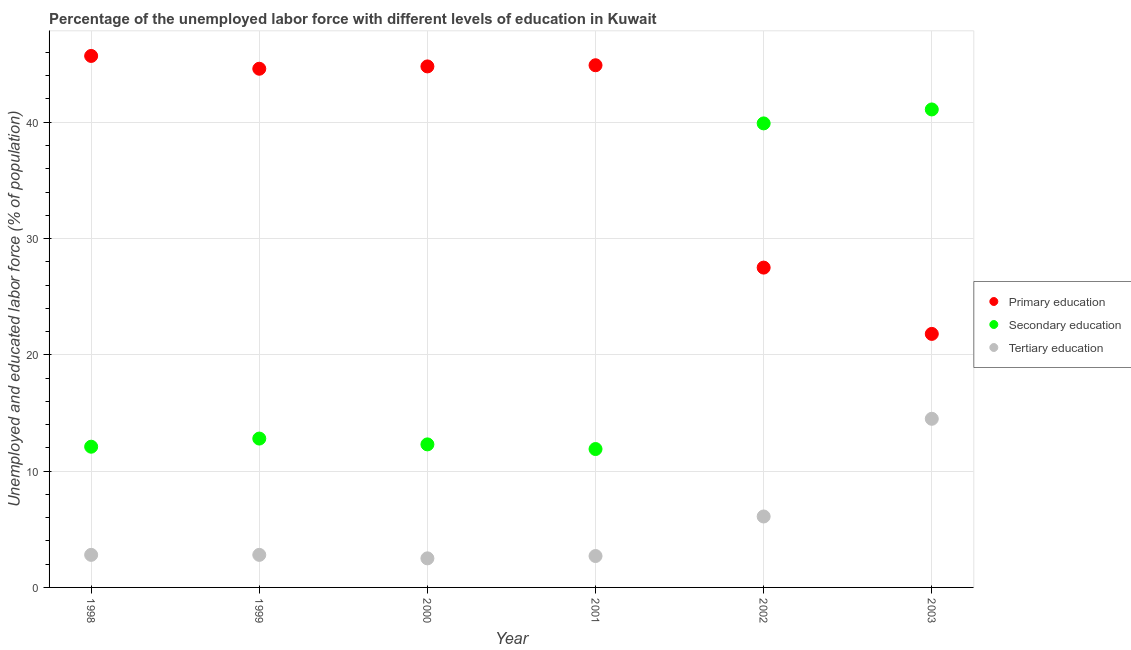Is the number of dotlines equal to the number of legend labels?
Provide a succinct answer. Yes. What is the percentage of labor force who received tertiary education in 2002?
Your answer should be compact. 6.1. Across all years, what is the maximum percentage of labor force who received primary education?
Your answer should be very brief. 45.7. Across all years, what is the minimum percentage of labor force who received primary education?
Make the answer very short. 21.8. In which year was the percentage of labor force who received secondary education maximum?
Provide a short and direct response. 2003. In which year was the percentage of labor force who received primary education minimum?
Ensure brevity in your answer.  2003. What is the total percentage of labor force who received secondary education in the graph?
Your answer should be very brief. 130.1. What is the difference between the percentage of labor force who received primary education in 2002 and that in 2003?
Your answer should be very brief. 5.7. What is the difference between the percentage of labor force who received tertiary education in 2002 and the percentage of labor force who received secondary education in 1998?
Provide a short and direct response. -6. What is the average percentage of labor force who received primary education per year?
Offer a very short reply. 38.22. In the year 2003, what is the difference between the percentage of labor force who received tertiary education and percentage of labor force who received secondary education?
Offer a terse response. -26.6. In how many years, is the percentage of labor force who received primary education greater than 16 %?
Ensure brevity in your answer.  6. What is the ratio of the percentage of labor force who received secondary education in 1999 to that in 2001?
Your answer should be very brief. 1.08. Is the percentage of labor force who received primary education in 1998 less than that in 2003?
Keep it short and to the point. No. What is the difference between the highest and the second highest percentage of labor force who received primary education?
Your answer should be compact. 0.8. What is the difference between the highest and the lowest percentage of labor force who received primary education?
Ensure brevity in your answer.  23.9. In how many years, is the percentage of labor force who received primary education greater than the average percentage of labor force who received primary education taken over all years?
Your answer should be compact. 4. Is the sum of the percentage of labor force who received secondary education in 1999 and 2003 greater than the maximum percentage of labor force who received tertiary education across all years?
Your answer should be compact. Yes. How many dotlines are there?
Your answer should be very brief. 3. Does the graph contain any zero values?
Ensure brevity in your answer.  No. Does the graph contain grids?
Make the answer very short. Yes. How many legend labels are there?
Offer a very short reply. 3. How are the legend labels stacked?
Your answer should be very brief. Vertical. What is the title of the graph?
Your answer should be compact. Percentage of the unemployed labor force with different levels of education in Kuwait. Does "Liquid fuel" appear as one of the legend labels in the graph?
Make the answer very short. No. What is the label or title of the Y-axis?
Ensure brevity in your answer.  Unemployed and educated labor force (% of population). What is the Unemployed and educated labor force (% of population) of Primary education in 1998?
Provide a short and direct response. 45.7. What is the Unemployed and educated labor force (% of population) of Secondary education in 1998?
Make the answer very short. 12.1. What is the Unemployed and educated labor force (% of population) in Tertiary education in 1998?
Ensure brevity in your answer.  2.8. What is the Unemployed and educated labor force (% of population) of Primary education in 1999?
Offer a very short reply. 44.6. What is the Unemployed and educated labor force (% of population) of Secondary education in 1999?
Make the answer very short. 12.8. What is the Unemployed and educated labor force (% of population) in Tertiary education in 1999?
Your answer should be compact. 2.8. What is the Unemployed and educated labor force (% of population) in Primary education in 2000?
Keep it short and to the point. 44.8. What is the Unemployed and educated labor force (% of population) in Secondary education in 2000?
Offer a terse response. 12.3. What is the Unemployed and educated labor force (% of population) of Tertiary education in 2000?
Offer a very short reply. 2.5. What is the Unemployed and educated labor force (% of population) in Primary education in 2001?
Provide a short and direct response. 44.9. What is the Unemployed and educated labor force (% of population) in Secondary education in 2001?
Offer a terse response. 11.9. What is the Unemployed and educated labor force (% of population) of Tertiary education in 2001?
Keep it short and to the point. 2.7. What is the Unemployed and educated labor force (% of population) of Primary education in 2002?
Offer a very short reply. 27.5. What is the Unemployed and educated labor force (% of population) of Secondary education in 2002?
Provide a succinct answer. 39.9. What is the Unemployed and educated labor force (% of population) in Tertiary education in 2002?
Offer a very short reply. 6.1. What is the Unemployed and educated labor force (% of population) in Primary education in 2003?
Provide a short and direct response. 21.8. What is the Unemployed and educated labor force (% of population) of Secondary education in 2003?
Your response must be concise. 41.1. Across all years, what is the maximum Unemployed and educated labor force (% of population) in Primary education?
Offer a terse response. 45.7. Across all years, what is the maximum Unemployed and educated labor force (% of population) in Secondary education?
Ensure brevity in your answer.  41.1. Across all years, what is the minimum Unemployed and educated labor force (% of population) of Primary education?
Provide a short and direct response. 21.8. Across all years, what is the minimum Unemployed and educated labor force (% of population) in Secondary education?
Make the answer very short. 11.9. What is the total Unemployed and educated labor force (% of population) in Primary education in the graph?
Keep it short and to the point. 229.3. What is the total Unemployed and educated labor force (% of population) in Secondary education in the graph?
Your response must be concise. 130.1. What is the total Unemployed and educated labor force (% of population) in Tertiary education in the graph?
Your response must be concise. 31.4. What is the difference between the Unemployed and educated labor force (% of population) in Tertiary education in 1998 and that in 1999?
Give a very brief answer. 0. What is the difference between the Unemployed and educated labor force (% of population) of Secondary education in 1998 and that in 2000?
Ensure brevity in your answer.  -0.2. What is the difference between the Unemployed and educated labor force (% of population) in Tertiary education in 1998 and that in 2000?
Make the answer very short. 0.3. What is the difference between the Unemployed and educated labor force (% of population) of Primary education in 1998 and that in 2001?
Your answer should be very brief. 0.8. What is the difference between the Unemployed and educated labor force (% of population) in Secondary education in 1998 and that in 2001?
Your response must be concise. 0.2. What is the difference between the Unemployed and educated labor force (% of population) in Secondary education in 1998 and that in 2002?
Your answer should be compact. -27.8. What is the difference between the Unemployed and educated labor force (% of population) in Tertiary education in 1998 and that in 2002?
Your answer should be compact. -3.3. What is the difference between the Unemployed and educated labor force (% of population) in Primary education in 1998 and that in 2003?
Ensure brevity in your answer.  23.9. What is the difference between the Unemployed and educated labor force (% of population) in Primary education in 1999 and that in 2000?
Your response must be concise. -0.2. What is the difference between the Unemployed and educated labor force (% of population) in Tertiary education in 1999 and that in 2000?
Provide a short and direct response. 0.3. What is the difference between the Unemployed and educated labor force (% of population) in Primary education in 1999 and that in 2001?
Make the answer very short. -0.3. What is the difference between the Unemployed and educated labor force (% of population) of Secondary education in 1999 and that in 2002?
Provide a short and direct response. -27.1. What is the difference between the Unemployed and educated labor force (% of population) in Tertiary education in 1999 and that in 2002?
Keep it short and to the point. -3.3. What is the difference between the Unemployed and educated labor force (% of population) of Primary education in 1999 and that in 2003?
Offer a terse response. 22.8. What is the difference between the Unemployed and educated labor force (% of population) of Secondary education in 1999 and that in 2003?
Keep it short and to the point. -28.3. What is the difference between the Unemployed and educated labor force (% of population) in Tertiary education in 1999 and that in 2003?
Provide a short and direct response. -11.7. What is the difference between the Unemployed and educated labor force (% of population) of Primary education in 2000 and that in 2001?
Ensure brevity in your answer.  -0.1. What is the difference between the Unemployed and educated labor force (% of population) in Secondary education in 2000 and that in 2001?
Ensure brevity in your answer.  0.4. What is the difference between the Unemployed and educated labor force (% of population) in Tertiary education in 2000 and that in 2001?
Give a very brief answer. -0.2. What is the difference between the Unemployed and educated labor force (% of population) in Secondary education in 2000 and that in 2002?
Make the answer very short. -27.6. What is the difference between the Unemployed and educated labor force (% of population) in Secondary education in 2000 and that in 2003?
Offer a terse response. -28.8. What is the difference between the Unemployed and educated labor force (% of population) of Primary education in 2001 and that in 2002?
Your response must be concise. 17.4. What is the difference between the Unemployed and educated labor force (% of population) of Secondary education in 2001 and that in 2002?
Ensure brevity in your answer.  -28. What is the difference between the Unemployed and educated labor force (% of population) in Primary education in 2001 and that in 2003?
Your response must be concise. 23.1. What is the difference between the Unemployed and educated labor force (% of population) of Secondary education in 2001 and that in 2003?
Your answer should be very brief. -29.2. What is the difference between the Unemployed and educated labor force (% of population) of Tertiary education in 2001 and that in 2003?
Your answer should be very brief. -11.8. What is the difference between the Unemployed and educated labor force (% of population) in Secondary education in 2002 and that in 2003?
Make the answer very short. -1.2. What is the difference between the Unemployed and educated labor force (% of population) of Primary education in 1998 and the Unemployed and educated labor force (% of population) of Secondary education in 1999?
Offer a terse response. 32.9. What is the difference between the Unemployed and educated labor force (% of population) of Primary education in 1998 and the Unemployed and educated labor force (% of population) of Tertiary education in 1999?
Your answer should be very brief. 42.9. What is the difference between the Unemployed and educated labor force (% of population) of Primary education in 1998 and the Unemployed and educated labor force (% of population) of Secondary education in 2000?
Provide a succinct answer. 33.4. What is the difference between the Unemployed and educated labor force (% of population) of Primary education in 1998 and the Unemployed and educated labor force (% of population) of Tertiary education in 2000?
Your answer should be compact. 43.2. What is the difference between the Unemployed and educated labor force (% of population) of Secondary education in 1998 and the Unemployed and educated labor force (% of population) of Tertiary education in 2000?
Make the answer very short. 9.6. What is the difference between the Unemployed and educated labor force (% of population) in Primary education in 1998 and the Unemployed and educated labor force (% of population) in Secondary education in 2001?
Keep it short and to the point. 33.8. What is the difference between the Unemployed and educated labor force (% of population) in Primary education in 1998 and the Unemployed and educated labor force (% of population) in Tertiary education in 2001?
Give a very brief answer. 43. What is the difference between the Unemployed and educated labor force (% of population) of Primary education in 1998 and the Unemployed and educated labor force (% of population) of Secondary education in 2002?
Provide a short and direct response. 5.8. What is the difference between the Unemployed and educated labor force (% of population) in Primary education in 1998 and the Unemployed and educated labor force (% of population) in Tertiary education in 2002?
Your answer should be compact. 39.6. What is the difference between the Unemployed and educated labor force (% of population) of Secondary education in 1998 and the Unemployed and educated labor force (% of population) of Tertiary education in 2002?
Provide a succinct answer. 6. What is the difference between the Unemployed and educated labor force (% of population) of Primary education in 1998 and the Unemployed and educated labor force (% of population) of Secondary education in 2003?
Your answer should be compact. 4.6. What is the difference between the Unemployed and educated labor force (% of population) in Primary education in 1998 and the Unemployed and educated labor force (% of population) in Tertiary education in 2003?
Offer a very short reply. 31.2. What is the difference between the Unemployed and educated labor force (% of population) of Secondary education in 1998 and the Unemployed and educated labor force (% of population) of Tertiary education in 2003?
Your answer should be compact. -2.4. What is the difference between the Unemployed and educated labor force (% of population) in Primary education in 1999 and the Unemployed and educated labor force (% of population) in Secondary education in 2000?
Give a very brief answer. 32.3. What is the difference between the Unemployed and educated labor force (% of population) of Primary education in 1999 and the Unemployed and educated labor force (% of population) of Tertiary education in 2000?
Offer a terse response. 42.1. What is the difference between the Unemployed and educated labor force (% of population) in Secondary education in 1999 and the Unemployed and educated labor force (% of population) in Tertiary education in 2000?
Give a very brief answer. 10.3. What is the difference between the Unemployed and educated labor force (% of population) in Primary education in 1999 and the Unemployed and educated labor force (% of population) in Secondary education in 2001?
Offer a terse response. 32.7. What is the difference between the Unemployed and educated labor force (% of population) in Primary education in 1999 and the Unemployed and educated labor force (% of population) in Tertiary education in 2001?
Offer a terse response. 41.9. What is the difference between the Unemployed and educated labor force (% of population) of Primary education in 1999 and the Unemployed and educated labor force (% of population) of Tertiary education in 2002?
Ensure brevity in your answer.  38.5. What is the difference between the Unemployed and educated labor force (% of population) of Secondary education in 1999 and the Unemployed and educated labor force (% of population) of Tertiary education in 2002?
Make the answer very short. 6.7. What is the difference between the Unemployed and educated labor force (% of population) of Primary education in 1999 and the Unemployed and educated labor force (% of population) of Secondary education in 2003?
Ensure brevity in your answer.  3.5. What is the difference between the Unemployed and educated labor force (% of population) in Primary education in 1999 and the Unemployed and educated labor force (% of population) in Tertiary education in 2003?
Offer a terse response. 30.1. What is the difference between the Unemployed and educated labor force (% of population) in Secondary education in 1999 and the Unemployed and educated labor force (% of population) in Tertiary education in 2003?
Give a very brief answer. -1.7. What is the difference between the Unemployed and educated labor force (% of population) of Primary education in 2000 and the Unemployed and educated labor force (% of population) of Secondary education in 2001?
Give a very brief answer. 32.9. What is the difference between the Unemployed and educated labor force (% of population) of Primary education in 2000 and the Unemployed and educated labor force (% of population) of Tertiary education in 2001?
Your response must be concise. 42.1. What is the difference between the Unemployed and educated labor force (% of population) of Primary education in 2000 and the Unemployed and educated labor force (% of population) of Tertiary education in 2002?
Offer a terse response. 38.7. What is the difference between the Unemployed and educated labor force (% of population) in Primary education in 2000 and the Unemployed and educated labor force (% of population) in Secondary education in 2003?
Offer a terse response. 3.7. What is the difference between the Unemployed and educated labor force (% of population) in Primary education in 2000 and the Unemployed and educated labor force (% of population) in Tertiary education in 2003?
Offer a terse response. 30.3. What is the difference between the Unemployed and educated labor force (% of population) of Secondary education in 2000 and the Unemployed and educated labor force (% of population) of Tertiary education in 2003?
Offer a very short reply. -2.2. What is the difference between the Unemployed and educated labor force (% of population) in Primary education in 2001 and the Unemployed and educated labor force (% of population) in Secondary education in 2002?
Offer a very short reply. 5. What is the difference between the Unemployed and educated labor force (% of population) in Primary education in 2001 and the Unemployed and educated labor force (% of population) in Tertiary education in 2002?
Offer a terse response. 38.8. What is the difference between the Unemployed and educated labor force (% of population) of Primary education in 2001 and the Unemployed and educated labor force (% of population) of Secondary education in 2003?
Your answer should be very brief. 3.8. What is the difference between the Unemployed and educated labor force (% of population) in Primary education in 2001 and the Unemployed and educated labor force (% of population) in Tertiary education in 2003?
Provide a succinct answer. 30.4. What is the difference between the Unemployed and educated labor force (% of population) of Secondary education in 2002 and the Unemployed and educated labor force (% of population) of Tertiary education in 2003?
Your answer should be compact. 25.4. What is the average Unemployed and educated labor force (% of population) in Primary education per year?
Ensure brevity in your answer.  38.22. What is the average Unemployed and educated labor force (% of population) in Secondary education per year?
Offer a very short reply. 21.68. What is the average Unemployed and educated labor force (% of population) in Tertiary education per year?
Offer a terse response. 5.23. In the year 1998, what is the difference between the Unemployed and educated labor force (% of population) of Primary education and Unemployed and educated labor force (% of population) of Secondary education?
Ensure brevity in your answer.  33.6. In the year 1998, what is the difference between the Unemployed and educated labor force (% of population) in Primary education and Unemployed and educated labor force (% of population) in Tertiary education?
Your answer should be very brief. 42.9. In the year 1998, what is the difference between the Unemployed and educated labor force (% of population) in Secondary education and Unemployed and educated labor force (% of population) in Tertiary education?
Your answer should be very brief. 9.3. In the year 1999, what is the difference between the Unemployed and educated labor force (% of population) in Primary education and Unemployed and educated labor force (% of population) in Secondary education?
Provide a succinct answer. 31.8. In the year 1999, what is the difference between the Unemployed and educated labor force (% of population) in Primary education and Unemployed and educated labor force (% of population) in Tertiary education?
Your response must be concise. 41.8. In the year 2000, what is the difference between the Unemployed and educated labor force (% of population) in Primary education and Unemployed and educated labor force (% of population) in Secondary education?
Offer a very short reply. 32.5. In the year 2000, what is the difference between the Unemployed and educated labor force (% of population) in Primary education and Unemployed and educated labor force (% of population) in Tertiary education?
Offer a terse response. 42.3. In the year 2001, what is the difference between the Unemployed and educated labor force (% of population) of Primary education and Unemployed and educated labor force (% of population) of Tertiary education?
Offer a terse response. 42.2. In the year 2002, what is the difference between the Unemployed and educated labor force (% of population) of Primary education and Unemployed and educated labor force (% of population) of Secondary education?
Offer a very short reply. -12.4. In the year 2002, what is the difference between the Unemployed and educated labor force (% of population) in Primary education and Unemployed and educated labor force (% of population) in Tertiary education?
Keep it short and to the point. 21.4. In the year 2002, what is the difference between the Unemployed and educated labor force (% of population) of Secondary education and Unemployed and educated labor force (% of population) of Tertiary education?
Ensure brevity in your answer.  33.8. In the year 2003, what is the difference between the Unemployed and educated labor force (% of population) in Primary education and Unemployed and educated labor force (% of population) in Secondary education?
Provide a short and direct response. -19.3. In the year 2003, what is the difference between the Unemployed and educated labor force (% of population) in Primary education and Unemployed and educated labor force (% of population) in Tertiary education?
Provide a short and direct response. 7.3. In the year 2003, what is the difference between the Unemployed and educated labor force (% of population) in Secondary education and Unemployed and educated labor force (% of population) in Tertiary education?
Keep it short and to the point. 26.6. What is the ratio of the Unemployed and educated labor force (% of population) in Primary education in 1998 to that in 1999?
Provide a short and direct response. 1.02. What is the ratio of the Unemployed and educated labor force (% of population) in Secondary education in 1998 to that in 1999?
Keep it short and to the point. 0.95. What is the ratio of the Unemployed and educated labor force (% of population) of Primary education in 1998 to that in 2000?
Your answer should be compact. 1.02. What is the ratio of the Unemployed and educated labor force (% of population) of Secondary education in 1998 to that in 2000?
Your answer should be very brief. 0.98. What is the ratio of the Unemployed and educated labor force (% of population) in Tertiary education in 1998 to that in 2000?
Offer a very short reply. 1.12. What is the ratio of the Unemployed and educated labor force (% of population) of Primary education in 1998 to that in 2001?
Give a very brief answer. 1.02. What is the ratio of the Unemployed and educated labor force (% of population) of Secondary education in 1998 to that in 2001?
Your response must be concise. 1.02. What is the ratio of the Unemployed and educated labor force (% of population) in Tertiary education in 1998 to that in 2001?
Your response must be concise. 1.04. What is the ratio of the Unemployed and educated labor force (% of population) in Primary education in 1998 to that in 2002?
Offer a terse response. 1.66. What is the ratio of the Unemployed and educated labor force (% of population) of Secondary education in 1998 to that in 2002?
Provide a short and direct response. 0.3. What is the ratio of the Unemployed and educated labor force (% of population) in Tertiary education in 1998 to that in 2002?
Keep it short and to the point. 0.46. What is the ratio of the Unemployed and educated labor force (% of population) of Primary education in 1998 to that in 2003?
Ensure brevity in your answer.  2.1. What is the ratio of the Unemployed and educated labor force (% of population) of Secondary education in 1998 to that in 2003?
Ensure brevity in your answer.  0.29. What is the ratio of the Unemployed and educated labor force (% of population) of Tertiary education in 1998 to that in 2003?
Ensure brevity in your answer.  0.19. What is the ratio of the Unemployed and educated labor force (% of population) in Secondary education in 1999 to that in 2000?
Give a very brief answer. 1.04. What is the ratio of the Unemployed and educated labor force (% of population) of Tertiary education in 1999 to that in 2000?
Provide a short and direct response. 1.12. What is the ratio of the Unemployed and educated labor force (% of population) of Secondary education in 1999 to that in 2001?
Offer a terse response. 1.08. What is the ratio of the Unemployed and educated labor force (% of population) in Tertiary education in 1999 to that in 2001?
Ensure brevity in your answer.  1.04. What is the ratio of the Unemployed and educated labor force (% of population) of Primary education in 1999 to that in 2002?
Offer a very short reply. 1.62. What is the ratio of the Unemployed and educated labor force (% of population) of Secondary education in 1999 to that in 2002?
Provide a succinct answer. 0.32. What is the ratio of the Unemployed and educated labor force (% of population) of Tertiary education in 1999 to that in 2002?
Make the answer very short. 0.46. What is the ratio of the Unemployed and educated labor force (% of population) in Primary education in 1999 to that in 2003?
Make the answer very short. 2.05. What is the ratio of the Unemployed and educated labor force (% of population) of Secondary education in 1999 to that in 2003?
Provide a succinct answer. 0.31. What is the ratio of the Unemployed and educated labor force (% of population) in Tertiary education in 1999 to that in 2003?
Provide a succinct answer. 0.19. What is the ratio of the Unemployed and educated labor force (% of population) of Secondary education in 2000 to that in 2001?
Provide a succinct answer. 1.03. What is the ratio of the Unemployed and educated labor force (% of population) of Tertiary education in 2000 to that in 2001?
Your answer should be compact. 0.93. What is the ratio of the Unemployed and educated labor force (% of population) in Primary education in 2000 to that in 2002?
Provide a short and direct response. 1.63. What is the ratio of the Unemployed and educated labor force (% of population) in Secondary education in 2000 to that in 2002?
Give a very brief answer. 0.31. What is the ratio of the Unemployed and educated labor force (% of population) in Tertiary education in 2000 to that in 2002?
Ensure brevity in your answer.  0.41. What is the ratio of the Unemployed and educated labor force (% of population) of Primary education in 2000 to that in 2003?
Your answer should be compact. 2.06. What is the ratio of the Unemployed and educated labor force (% of population) in Secondary education in 2000 to that in 2003?
Provide a succinct answer. 0.3. What is the ratio of the Unemployed and educated labor force (% of population) of Tertiary education in 2000 to that in 2003?
Provide a succinct answer. 0.17. What is the ratio of the Unemployed and educated labor force (% of population) of Primary education in 2001 to that in 2002?
Your answer should be very brief. 1.63. What is the ratio of the Unemployed and educated labor force (% of population) in Secondary education in 2001 to that in 2002?
Offer a very short reply. 0.3. What is the ratio of the Unemployed and educated labor force (% of population) in Tertiary education in 2001 to that in 2002?
Provide a succinct answer. 0.44. What is the ratio of the Unemployed and educated labor force (% of population) in Primary education in 2001 to that in 2003?
Keep it short and to the point. 2.06. What is the ratio of the Unemployed and educated labor force (% of population) in Secondary education in 2001 to that in 2003?
Your answer should be compact. 0.29. What is the ratio of the Unemployed and educated labor force (% of population) in Tertiary education in 2001 to that in 2003?
Keep it short and to the point. 0.19. What is the ratio of the Unemployed and educated labor force (% of population) in Primary education in 2002 to that in 2003?
Your answer should be very brief. 1.26. What is the ratio of the Unemployed and educated labor force (% of population) of Secondary education in 2002 to that in 2003?
Provide a succinct answer. 0.97. What is the ratio of the Unemployed and educated labor force (% of population) in Tertiary education in 2002 to that in 2003?
Offer a very short reply. 0.42. What is the difference between the highest and the second highest Unemployed and educated labor force (% of population) of Primary education?
Give a very brief answer. 0.8. What is the difference between the highest and the second highest Unemployed and educated labor force (% of population) of Secondary education?
Keep it short and to the point. 1.2. What is the difference between the highest and the second highest Unemployed and educated labor force (% of population) in Tertiary education?
Your answer should be compact. 8.4. What is the difference between the highest and the lowest Unemployed and educated labor force (% of population) of Primary education?
Provide a succinct answer. 23.9. What is the difference between the highest and the lowest Unemployed and educated labor force (% of population) of Secondary education?
Keep it short and to the point. 29.2. 